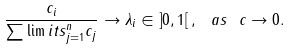Convert formula to latex. <formula><loc_0><loc_0><loc_500><loc_500>\frac { c _ { i } } { \sum \lim i t s _ { j = 1 } ^ { n } c _ { j } } \rightarrow \lambda _ { i } \in \left ] 0 , 1 \right [ , \ a s \ c \rightarrow 0 .</formula> 